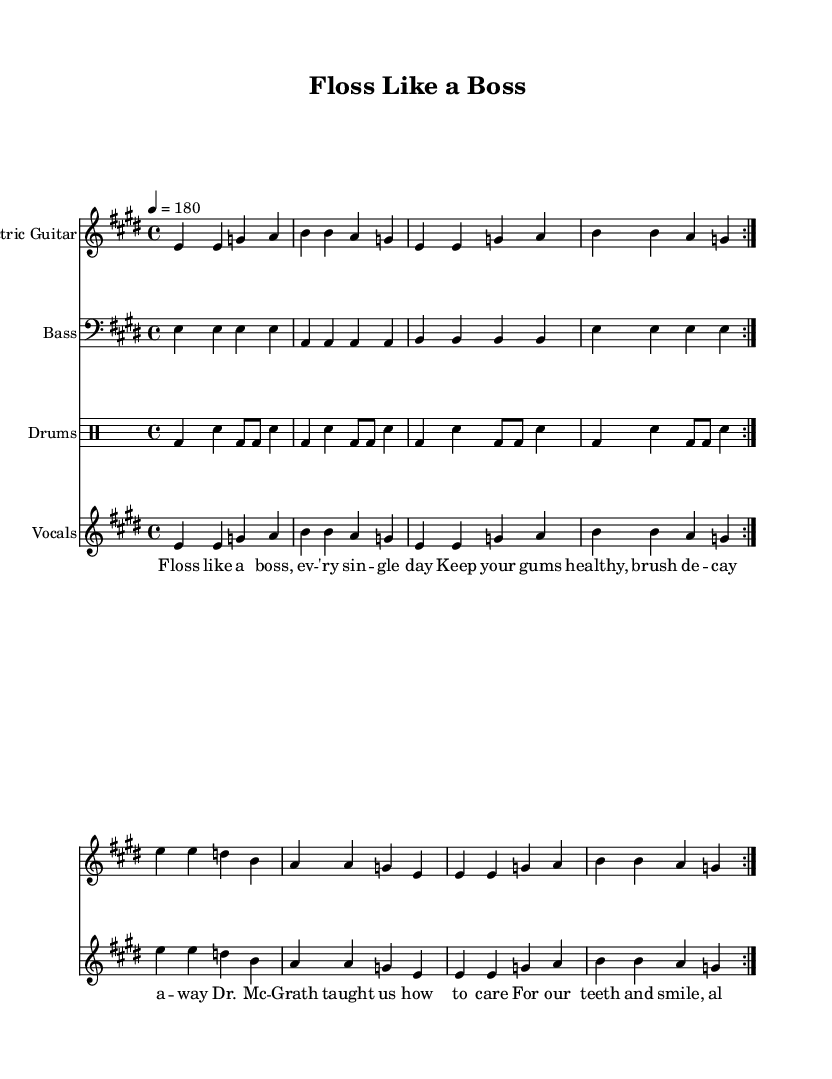What is the key signature of this music? The key signature is indicated by the number of sharps or flats at the beginning of the staff. In this piece, there are four sharps, indicating that the key signature is E major.
Answer: E major What is the time signature of the song? The time signature is found at the beginning of the staff and indicates how many beats are in each measure. Here, the time signature is 4/4, meaning there are four beats per measure.
Answer: 4/4 What is the tempo of the piece? The tempo is indicated at the beginning and is denoted by the number, which tells the speed of the music in beats per minute. This piece has a tempo of 180 beats per minute, indicating a fast-paced rhythm.
Answer: 180 How many measures are repeated in the sections? The repeat marks indicate the sections that are repeated, and in this case, there are 2 measures repeated as shown by the 'volta' directive. It applies to the sections of both electric guitar and vocals.
Answer: 2 What instrument is used for the bass part? The bass part is indicated by the instrument name on the staff. This music specifies a "Bass" instrument, which is one of the two main components in a punk ensemble driving the rhythm and harmony.
Answer: Bass What is the role of drums in this music piece? The role of drums, as noted in the music under the "Drums" staff, is to keep the rhythm and provide a backbeat that drives the energy typical of punk music. The rhythmic pattern is crucial for maintaining the fast-paced feel of the song.
Answer: Driving the rhythm 